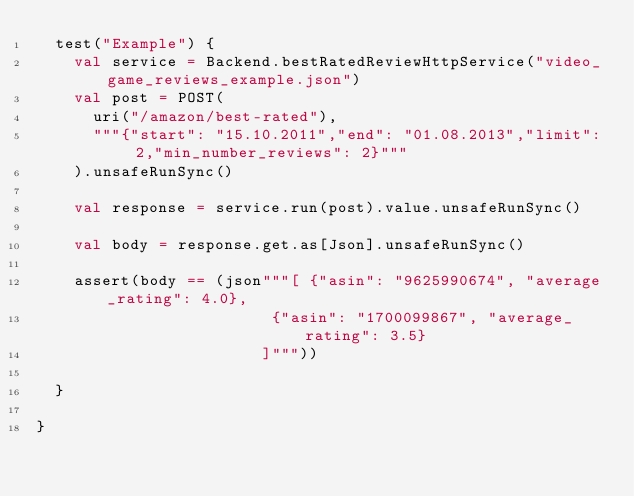<code> <loc_0><loc_0><loc_500><loc_500><_Scala_>  test("Example") {
    val service = Backend.bestRatedReviewHttpService("video_game_reviews_example.json")
    val post = POST(
      uri("/amazon/best-rated"),
      """{"start": "15.10.2011","end": "01.08.2013","limit": 2,"min_number_reviews": 2}"""
    ).unsafeRunSync()

    val response = service.run(post).value.unsafeRunSync()

    val body = response.get.as[Json].unsafeRunSync()

    assert(body == (json"""[ {"asin": "9625990674", "average_rating": 4.0},
                         {"asin": "1700099867", "average_rating": 3.5}
                        ]"""))

  }

}
</code> 